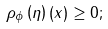Convert formula to latex. <formula><loc_0><loc_0><loc_500><loc_500>\rho _ { \phi } \left ( \eta \right ) ( x ) \geq 0 ;</formula> 